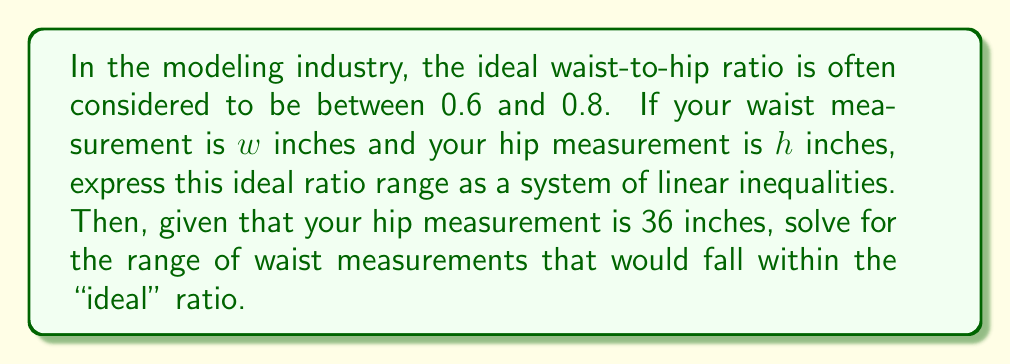What is the answer to this math problem? 1) First, let's express the waist-to-hip ratio as an inequality:

   $0.6 \leq \frac{w}{h} \leq 0.8$

2) We can split this into two separate inequalities:

   $\frac{w}{h} \geq 0.6$ and $\frac{w}{h} \leq 0.8$

3) Multiply both sides of each inequality by $h$:

   $w \geq 0.6h$ and $w \leq 0.8h$

4) Now we have our system of linear inequalities:

   $$\begin{cases}
   w \geq 0.6h \\
   w \leq 0.8h
   \end{cases}$$

5) Given that the hip measurement $h = 36$ inches, substitute this value:

   $$\begin{cases}
   w \geq 0.6(36) \\
   w \leq 0.8(36)
   \end{cases}$$

6) Simplify:

   $$\begin{cases}
   w \geq 21.6 \\
   w \leq 28.8
   \end{cases}$$

7) Therefore, for a hip measurement of 36 inches, the waist measurement should be between 21.6 and 28.8 inches to fall within the "ideal" ratio range.
Answer: $21.6 \leq w \leq 28.8$ 